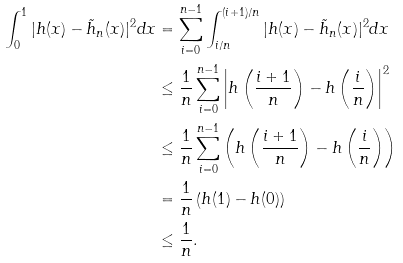Convert formula to latex. <formula><loc_0><loc_0><loc_500><loc_500>\int _ { 0 } ^ { 1 } | h ( x ) - \tilde { h } _ { n } ( x ) | ^ { 2 } d x & = \sum _ { i = 0 } ^ { n - 1 } \int _ { i / n } ^ { ( i + 1 ) / n } | h ( x ) - \tilde { h } _ { n } ( x ) | ^ { 2 } d x \\ & \leq \frac { 1 } { n } \sum _ { i = 0 } ^ { n - 1 } \left | h \left ( \frac { i + 1 } { n } \right ) - h \left ( \frac { i } { n } \right ) \right | ^ { 2 } \\ & \leq \frac { 1 } { n } \sum _ { i = 0 } ^ { n - 1 } \left ( h \left ( \frac { i + 1 } { n } \right ) - h \left ( \frac { i } { n } \right ) \right ) \\ & = \frac { 1 } { n } \left ( h ( 1 ) - h ( 0 ) \right ) \\ & \leq \frac { 1 } { n } .</formula> 